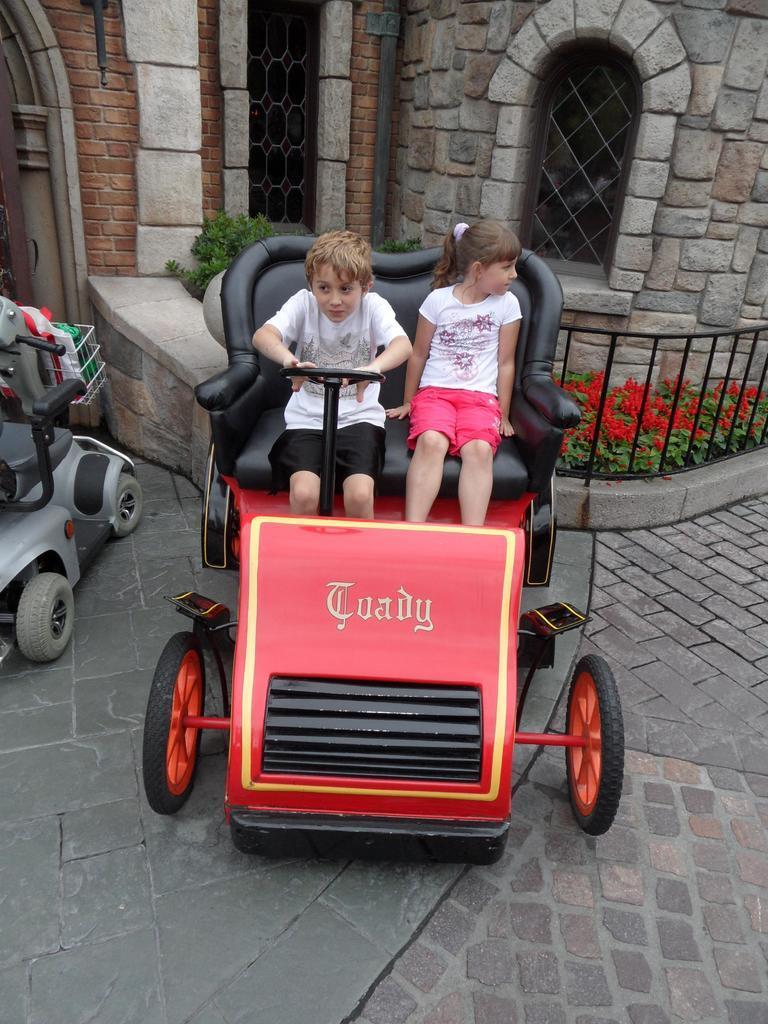Describe this image in one or two sentences. In this picture there is a girl who is wearing white t-shirt and red short. She is sitting beside the boy. Both of them sitting on the seat. Here we can see the cars. On the back we can see fencing, flowers and plants. On the top right there is a window. On the top we can see a building. 